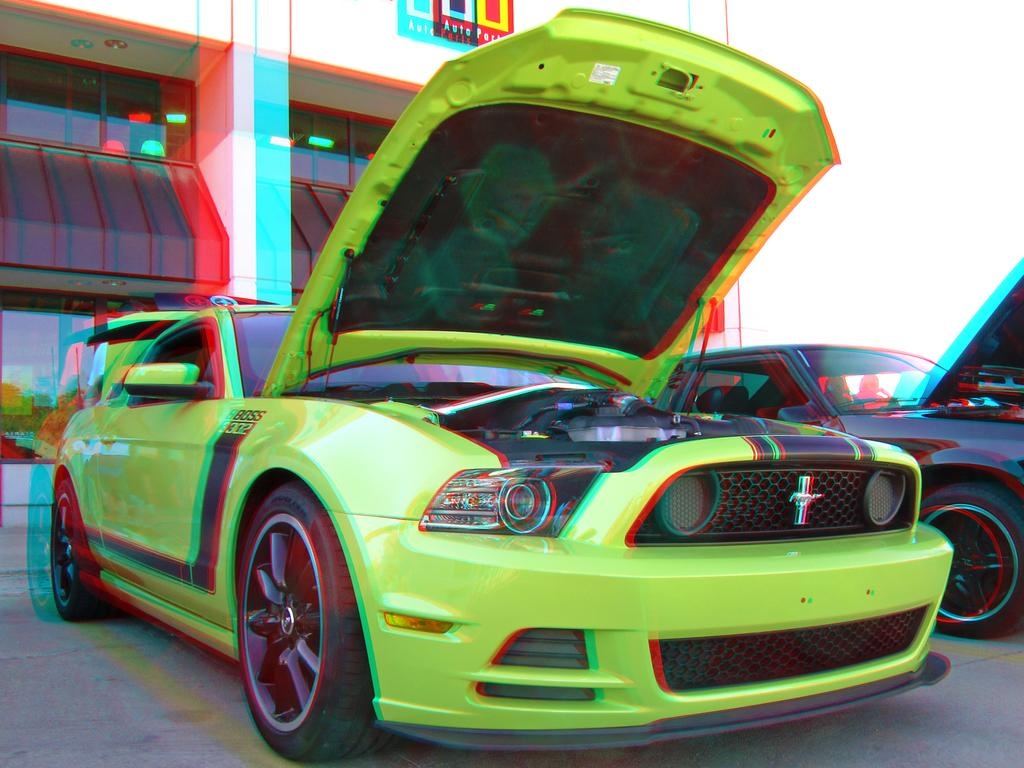How many cars are visible in the image? There are two cars in the image. Where are the cars located? The cars are on the road. What is visible behind the cars? There is a building behind the cars. What is the temper of the person driving the car on the left? There is no indication of a person driving the car in the image, nor is there any information about their temper. 